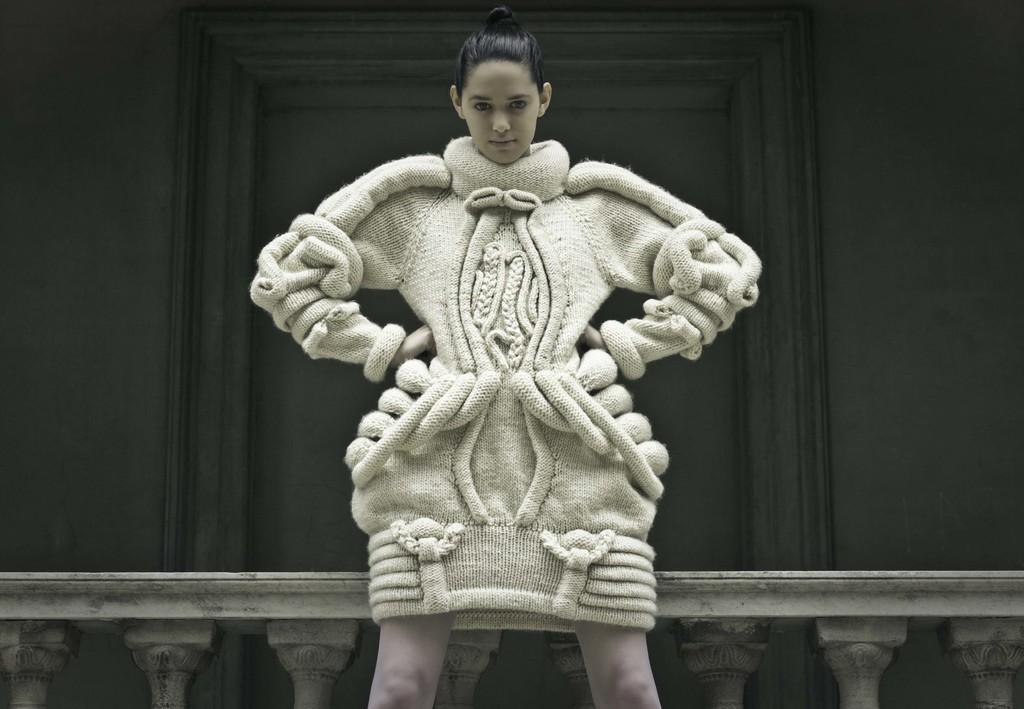Who is the main subject in the image? There is a person in the center of the image. What is the person wearing? The person is wearing a dress. What is the person's posture in the image? The person is standing. What can be seen in the background of the image? There is a wall, a guardrail, and at least one other object in the background of the image. What type of cakes are being served at the event in the image? There is no event or cakes present in the image; it features a person standing in front of a wall and a guardrail. What is the person eating for breakfast in the image? There is no indication of the person eating anything, let alone oatmeal, in the image. 